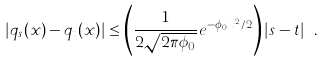Convert formula to latex. <formula><loc_0><loc_0><loc_500><loc_500>| q _ { s } ( x ) - q _ { t } ( x ) | \leq \left ( \frac { 1 } { 2 \sqrt { 2 \pi \phi _ { 0 } } } e ^ { - \phi _ { 0 } x ^ { 2 } / 2 } \right ) | s - t | \ .</formula> 